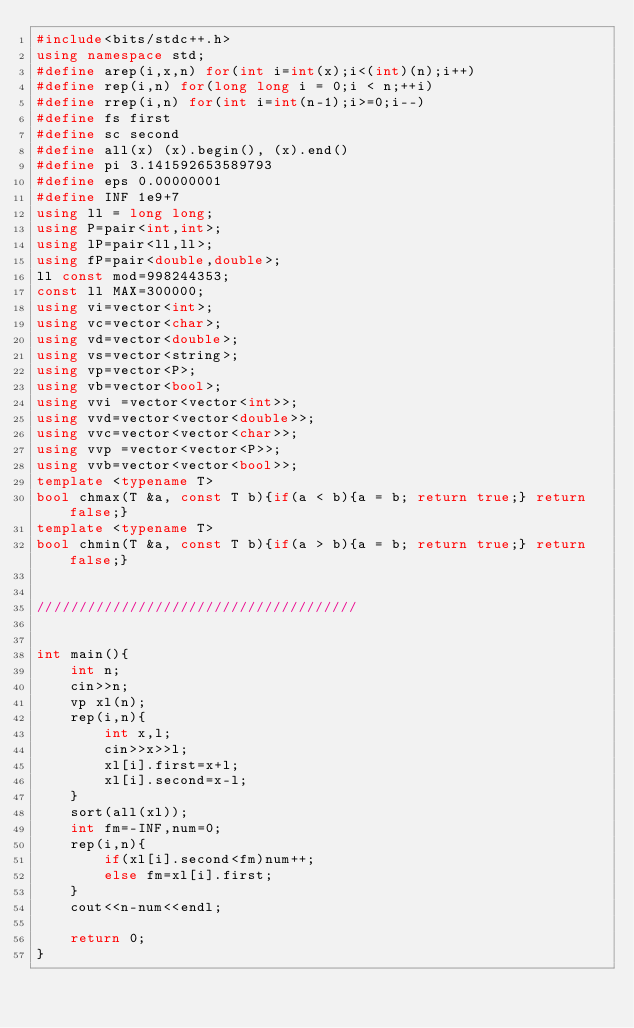<code> <loc_0><loc_0><loc_500><loc_500><_C++_>#include<bits/stdc++.h>
using namespace std;
#define arep(i,x,n) for(int i=int(x);i<(int)(n);i++)
#define rep(i,n) for(long long i = 0;i < n;++i)
#define rrep(i,n) for(int i=int(n-1);i>=0;i--)
#define fs first
#define sc second
#define all(x) (x).begin(), (x).end()
#define pi 3.141592653589793
#define eps 0.00000001
#define INF 1e9+7  
using ll = long long; 
using P=pair<int,int>;
using lP=pair<ll,ll>;
using fP=pair<double,double>;
ll const mod=998244353;
const ll MAX=300000;
using vi=vector<int>;
using vc=vector<char>;
using vd=vector<double>;
using vs=vector<string>;
using vp=vector<P>;
using vb=vector<bool>;
using vvi =vector<vector<int>>;
using vvd=vector<vector<double>>;
using vvc=vector<vector<char>>;
using vvp =vector<vector<P>>;
using vvb=vector<vector<bool>>;
template <typename T>
bool chmax(T &a, const T b){if(a < b){a = b; return true;} return false;}
template <typename T>
bool chmin(T &a, const T b){if(a > b){a = b; return true;} return false;}


//////////////////////////////////////


int main(){
    int n;
    cin>>n;
    vp xl(n);
    rep(i,n){
        int x,l;
        cin>>x>>l;
        xl[i].first=x+l;
        xl[i].second=x-l;
    }
    sort(all(xl));
    int fm=-INF,num=0;
    rep(i,n){
        if(xl[i].second<fm)num++;
        else fm=xl[i].first;
    }
    cout<<n-num<<endl;

    return 0;
}</code> 